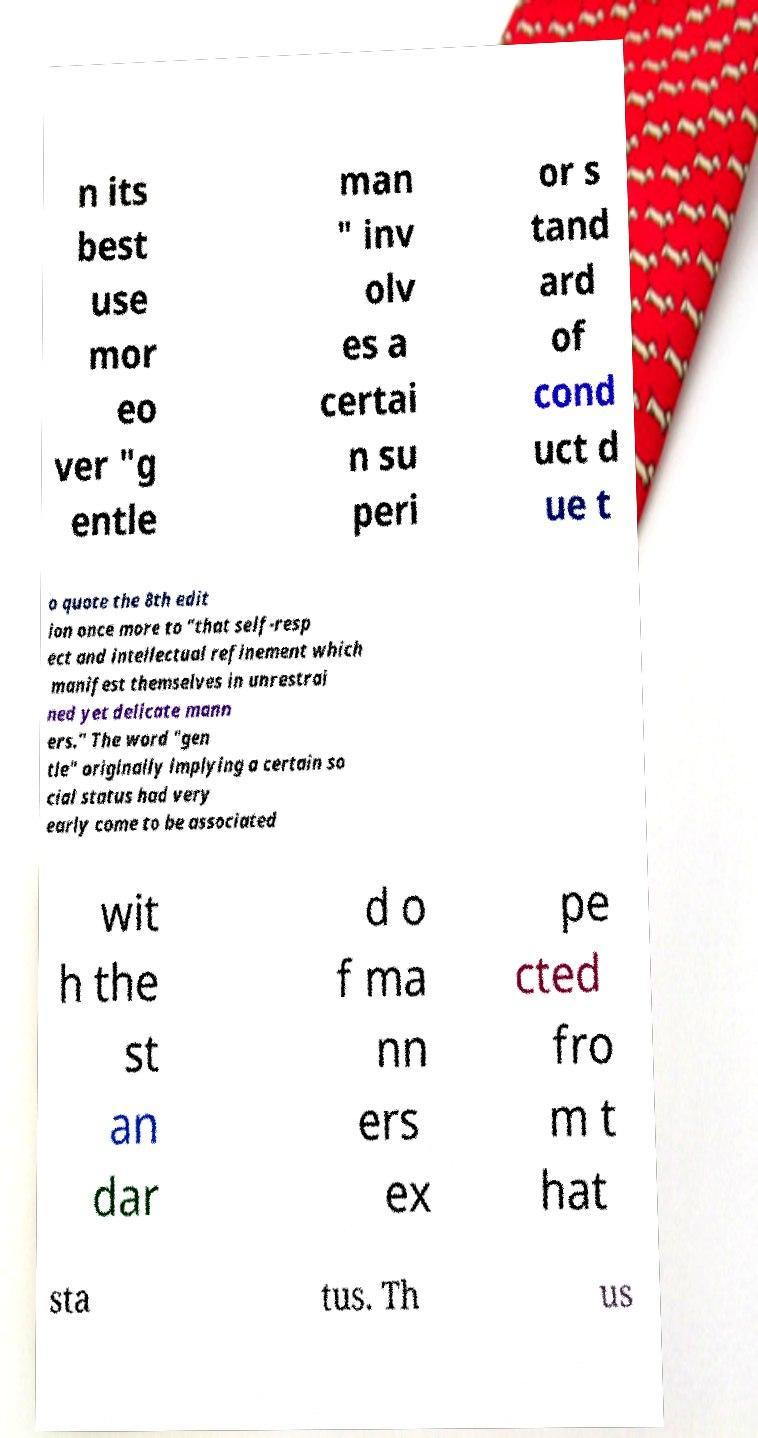What messages or text are displayed in this image? I need them in a readable, typed format. n its best use mor eo ver "g entle man " inv olv es a certai n su peri or s tand ard of cond uct d ue t o quote the 8th edit ion once more to "that self-resp ect and intellectual refinement which manifest themselves in unrestrai ned yet delicate mann ers." The word "gen tle" originally implying a certain so cial status had very early come to be associated wit h the st an dar d o f ma nn ers ex pe cted fro m t hat sta tus. Th us 